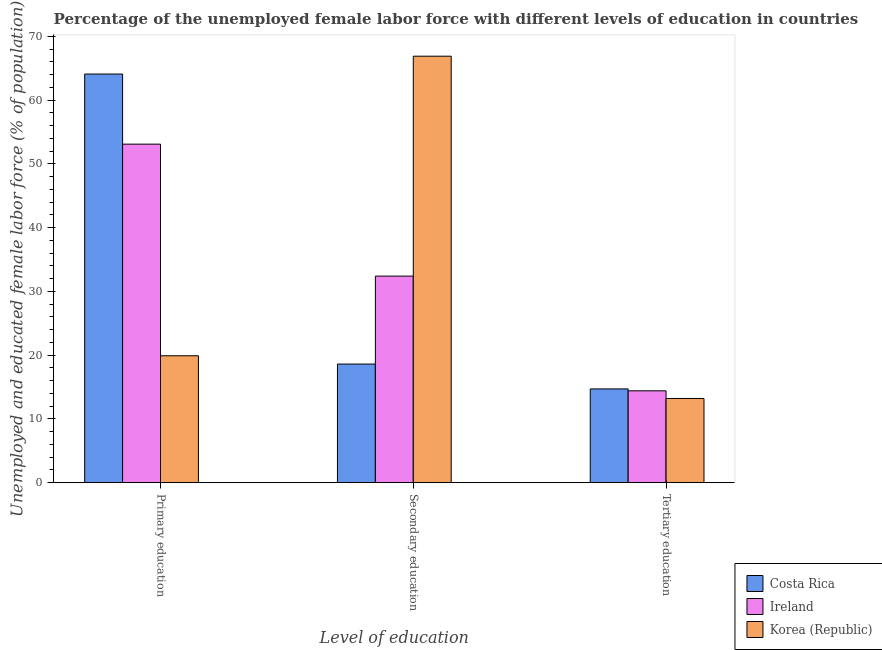Are the number of bars per tick equal to the number of legend labels?
Your answer should be very brief. Yes. How many bars are there on the 2nd tick from the left?
Ensure brevity in your answer.  3. How many bars are there on the 2nd tick from the right?
Your answer should be very brief. 3. What is the label of the 3rd group of bars from the left?
Ensure brevity in your answer.  Tertiary education. What is the percentage of female labor force who received primary education in Ireland?
Keep it short and to the point. 53.1. Across all countries, what is the maximum percentage of female labor force who received primary education?
Ensure brevity in your answer.  64.1. Across all countries, what is the minimum percentage of female labor force who received secondary education?
Your response must be concise. 18.6. In which country was the percentage of female labor force who received tertiary education maximum?
Give a very brief answer. Costa Rica. In which country was the percentage of female labor force who received secondary education minimum?
Ensure brevity in your answer.  Costa Rica. What is the total percentage of female labor force who received primary education in the graph?
Your answer should be compact. 137.1. What is the difference between the percentage of female labor force who received primary education in Costa Rica and that in Korea (Republic)?
Offer a terse response. 44.2. What is the difference between the percentage of female labor force who received tertiary education in Korea (Republic) and the percentage of female labor force who received secondary education in Ireland?
Make the answer very short. -19.2. What is the average percentage of female labor force who received tertiary education per country?
Offer a terse response. 14.1. What is the difference between the percentage of female labor force who received primary education and percentage of female labor force who received secondary education in Ireland?
Ensure brevity in your answer.  20.7. In how many countries, is the percentage of female labor force who received secondary education greater than 52 %?
Make the answer very short. 1. What is the ratio of the percentage of female labor force who received tertiary education in Ireland to that in Korea (Republic)?
Your response must be concise. 1.09. What is the difference between the highest and the second highest percentage of female labor force who received secondary education?
Offer a very short reply. 34.5. What is the difference between the highest and the lowest percentage of female labor force who received primary education?
Provide a succinct answer. 44.2. In how many countries, is the percentage of female labor force who received primary education greater than the average percentage of female labor force who received primary education taken over all countries?
Your response must be concise. 2. Is the sum of the percentage of female labor force who received tertiary education in Korea (Republic) and Costa Rica greater than the maximum percentage of female labor force who received secondary education across all countries?
Your answer should be very brief. No. What does the 2nd bar from the left in Secondary education represents?
Offer a very short reply. Ireland. How many bars are there?
Offer a terse response. 9. Are all the bars in the graph horizontal?
Your answer should be very brief. No. How many countries are there in the graph?
Offer a very short reply. 3. Are the values on the major ticks of Y-axis written in scientific E-notation?
Your response must be concise. No. Does the graph contain grids?
Offer a very short reply. No. Where does the legend appear in the graph?
Your answer should be very brief. Bottom right. What is the title of the graph?
Offer a terse response. Percentage of the unemployed female labor force with different levels of education in countries. What is the label or title of the X-axis?
Offer a very short reply. Level of education. What is the label or title of the Y-axis?
Make the answer very short. Unemployed and educated female labor force (% of population). What is the Unemployed and educated female labor force (% of population) of Costa Rica in Primary education?
Make the answer very short. 64.1. What is the Unemployed and educated female labor force (% of population) in Ireland in Primary education?
Your answer should be compact. 53.1. What is the Unemployed and educated female labor force (% of population) of Korea (Republic) in Primary education?
Provide a short and direct response. 19.9. What is the Unemployed and educated female labor force (% of population) of Costa Rica in Secondary education?
Your response must be concise. 18.6. What is the Unemployed and educated female labor force (% of population) of Ireland in Secondary education?
Ensure brevity in your answer.  32.4. What is the Unemployed and educated female labor force (% of population) of Korea (Republic) in Secondary education?
Offer a very short reply. 66.9. What is the Unemployed and educated female labor force (% of population) of Costa Rica in Tertiary education?
Provide a short and direct response. 14.7. What is the Unemployed and educated female labor force (% of population) in Ireland in Tertiary education?
Your answer should be compact. 14.4. What is the Unemployed and educated female labor force (% of population) of Korea (Republic) in Tertiary education?
Ensure brevity in your answer.  13.2. Across all Level of education, what is the maximum Unemployed and educated female labor force (% of population) of Costa Rica?
Make the answer very short. 64.1. Across all Level of education, what is the maximum Unemployed and educated female labor force (% of population) of Ireland?
Offer a very short reply. 53.1. Across all Level of education, what is the maximum Unemployed and educated female labor force (% of population) in Korea (Republic)?
Your answer should be very brief. 66.9. Across all Level of education, what is the minimum Unemployed and educated female labor force (% of population) in Costa Rica?
Make the answer very short. 14.7. Across all Level of education, what is the minimum Unemployed and educated female labor force (% of population) of Ireland?
Ensure brevity in your answer.  14.4. Across all Level of education, what is the minimum Unemployed and educated female labor force (% of population) in Korea (Republic)?
Give a very brief answer. 13.2. What is the total Unemployed and educated female labor force (% of population) of Costa Rica in the graph?
Provide a succinct answer. 97.4. What is the total Unemployed and educated female labor force (% of population) in Ireland in the graph?
Your answer should be compact. 99.9. What is the difference between the Unemployed and educated female labor force (% of population) of Costa Rica in Primary education and that in Secondary education?
Offer a very short reply. 45.5. What is the difference between the Unemployed and educated female labor force (% of population) in Ireland in Primary education and that in Secondary education?
Provide a short and direct response. 20.7. What is the difference between the Unemployed and educated female labor force (% of population) in Korea (Republic) in Primary education and that in Secondary education?
Offer a terse response. -47. What is the difference between the Unemployed and educated female labor force (% of population) in Costa Rica in Primary education and that in Tertiary education?
Your response must be concise. 49.4. What is the difference between the Unemployed and educated female labor force (% of population) in Ireland in Primary education and that in Tertiary education?
Offer a terse response. 38.7. What is the difference between the Unemployed and educated female labor force (% of population) in Korea (Republic) in Primary education and that in Tertiary education?
Provide a succinct answer. 6.7. What is the difference between the Unemployed and educated female labor force (% of population) of Korea (Republic) in Secondary education and that in Tertiary education?
Provide a short and direct response. 53.7. What is the difference between the Unemployed and educated female labor force (% of population) of Costa Rica in Primary education and the Unemployed and educated female labor force (% of population) of Ireland in Secondary education?
Provide a short and direct response. 31.7. What is the difference between the Unemployed and educated female labor force (% of population) of Ireland in Primary education and the Unemployed and educated female labor force (% of population) of Korea (Republic) in Secondary education?
Provide a short and direct response. -13.8. What is the difference between the Unemployed and educated female labor force (% of population) in Costa Rica in Primary education and the Unemployed and educated female labor force (% of population) in Ireland in Tertiary education?
Make the answer very short. 49.7. What is the difference between the Unemployed and educated female labor force (% of population) in Costa Rica in Primary education and the Unemployed and educated female labor force (% of population) in Korea (Republic) in Tertiary education?
Make the answer very short. 50.9. What is the difference between the Unemployed and educated female labor force (% of population) of Ireland in Primary education and the Unemployed and educated female labor force (% of population) of Korea (Republic) in Tertiary education?
Give a very brief answer. 39.9. What is the difference between the Unemployed and educated female labor force (% of population) in Costa Rica in Secondary education and the Unemployed and educated female labor force (% of population) in Korea (Republic) in Tertiary education?
Make the answer very short. 5.4. What is the average Unemployed and educated female labor force (% of population) of Costa Rica per Level of education?
Offer a very short reply. 32.47. What is the average Unemployed and educated female labor force (% of population) of Ireland per Level of education?
Offer a terse response. 33.3. What is the average Unemployed and educated female labor force (% of population) in Korea (Republic) per Level of education?
Provide a succinct answer. 33.33. What is the difference between the Unemployed and educated female labor force (% of population) of Costa Rica and Unemployed and educated female labor force (% of population) of Korea (Republic) in Primary education?
Offer a terse response. 44.2. What is the difference between the Unemployed and educated female labor force (% of population) of Ireland and Unemployed and educated female labor force (% of population) of Korea (Republic) in Primary education?
Offer a very short reply. 33.2. What is the difference between the Unemployed and educated female labor force (% of population) of Costa Rica and Unemployed and educated female labor force (% of population) of Ireland in Secondary education?
Make the answer very short. -13.8. What is the difference between the Unemployed and educated female labor force (% of population) in Costa Rica and Unemployed and educated female labor force (% of population) in Korea (Republic) in Secondary education?
Offer a terse response. -48.3. What is the difference between the Unemployed and educated female labor force (% of population) of Ireland and Unemployed and educated female labor force (% of population) of Korea (Republic) in Secondary education?
Your answer should be very brief. -34.5. What is the difference between the Unemployed and educated female labor force (% of population) in Costa Rica and Unemployed and educated female labor force (% of population) in Ireland in Tertiary education?
Keep it short and to the point. 0.3. What is the difference between the Unemployed and educated female labor force (% of population) in Costa Rica and Unemployed and educated female labor force (% of population) in Korea (Republic) in Tertiary education?
Provide a short and direct response. 1.5. What is the ratio of the Unemployed and educated female labor force (% of population) in Costa Rica in Primary education to that in Secondary education?
Make the answer very short. 3.45. What is the ratio of the Unemployed and educated female labor force (% of population) of Ireland in Primary education to that in Secondary education?
Your response must be concise. 1.64. What is the ratio of the Unemployed and educated female labor force (% of population) of Korea (Republic) in Primary education to that in Secondary education?
Make the answer very short. 0.3. What is the ratio of the Unemployed and educated female labor force (% of population) in Costa Rica in Primary education to that in Tertiary education?
Make the answer very short. 4.36. What is the ratio of the Unemployed and educated female labor force (% of population) in Ireland in Primary education to that in Tertiary education?
Your answer should be very brief. 3.69. What is the ratio of the Unemployed and educated female labor force (% of population) in Korea (Republic) in Primary education to that in Tertiary education?
Your answer should be compact. 1.51. What is the ratio of the Unemployed and educated female labor force (% of population) of Costa Rica in Secondary education to that in Tertiary education?
Your response must be concise. 1.27. What is the ratio of the Unemployed and educated female labor force (% of population) of Ireland in Secondary education to that in Tertiary education?
Provide a short and direct response. 2.25. What is the ratio of the Unemployed and educated female labor force (% of population) of Korea (Republic) in Secondary education to that in Tertiary education?
Give a very brief answer. 5.07. What is the difference between the highest and the second highest Unemployed and educated female labor force (% of population) of Costa Rica?
Keep it short and to the point. 45.5. What is the difference between the highest and the second highest Unemployed and educated female labor force (% of population) in Ireland?
Provide a succinct answer. 20.7. What is the difference between the highest and the lowest Unemployed and educated female labor force (% of population) of Costa Rica?
Your response must be concise. 49.4. What is the difference between the highest and the lowest Unemployed and educated female labor force (% of population) in Ireland?
Keep it short and to the point. 38.7. What is the difference between the highest and the lowest Unemployed and educated female labor force (% of population) of Korea (Republic)?
Offer a terse response. 53.7. 